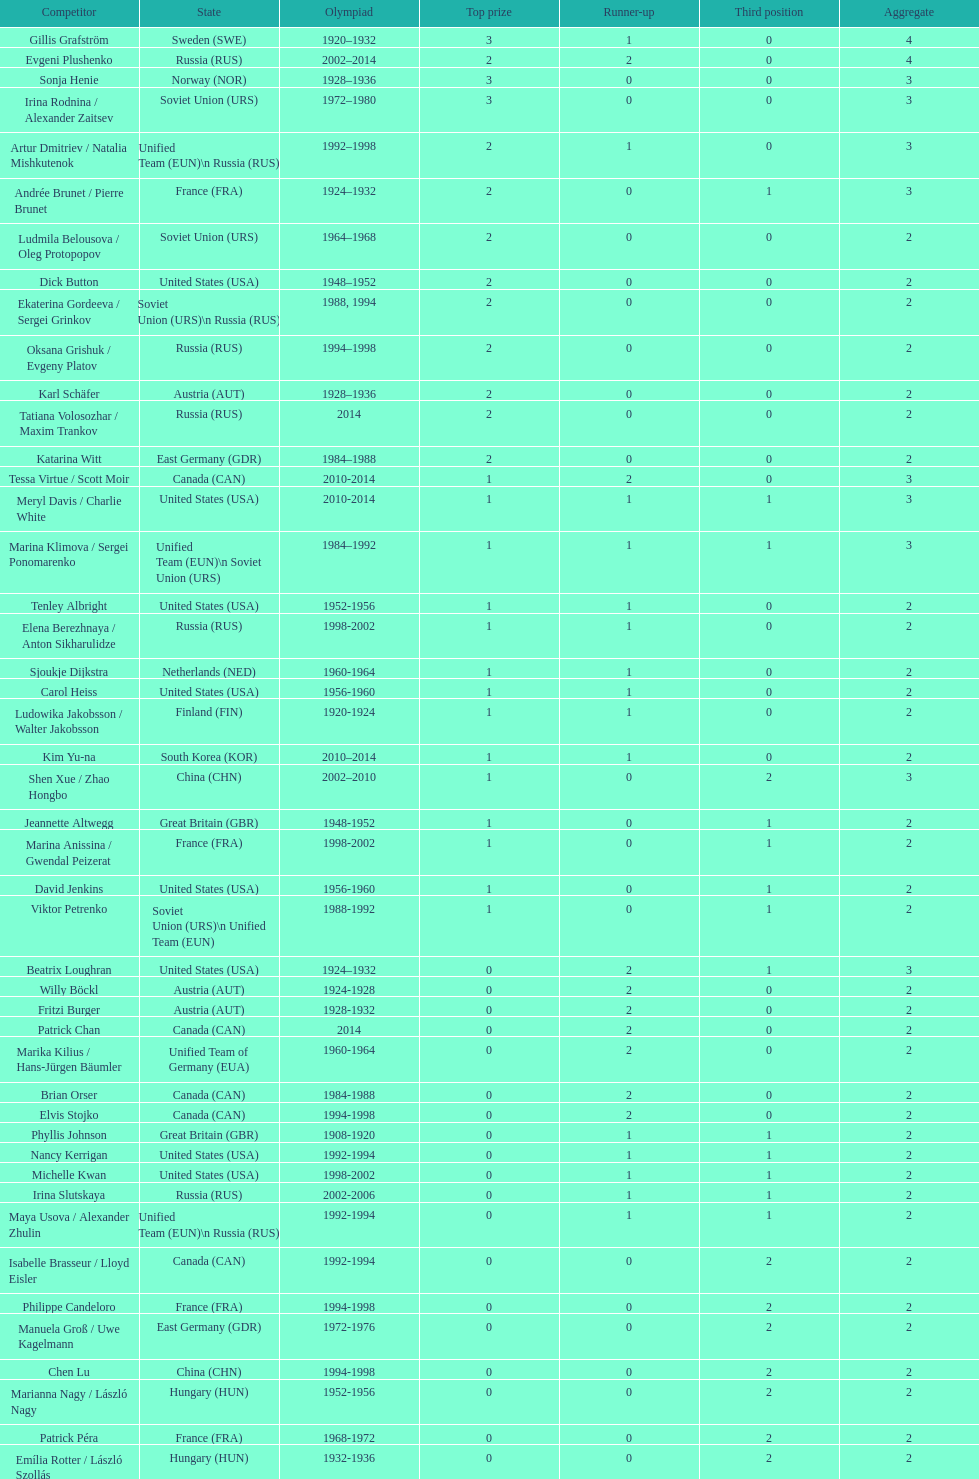How many medals have sweden and norway won combined? 7. 